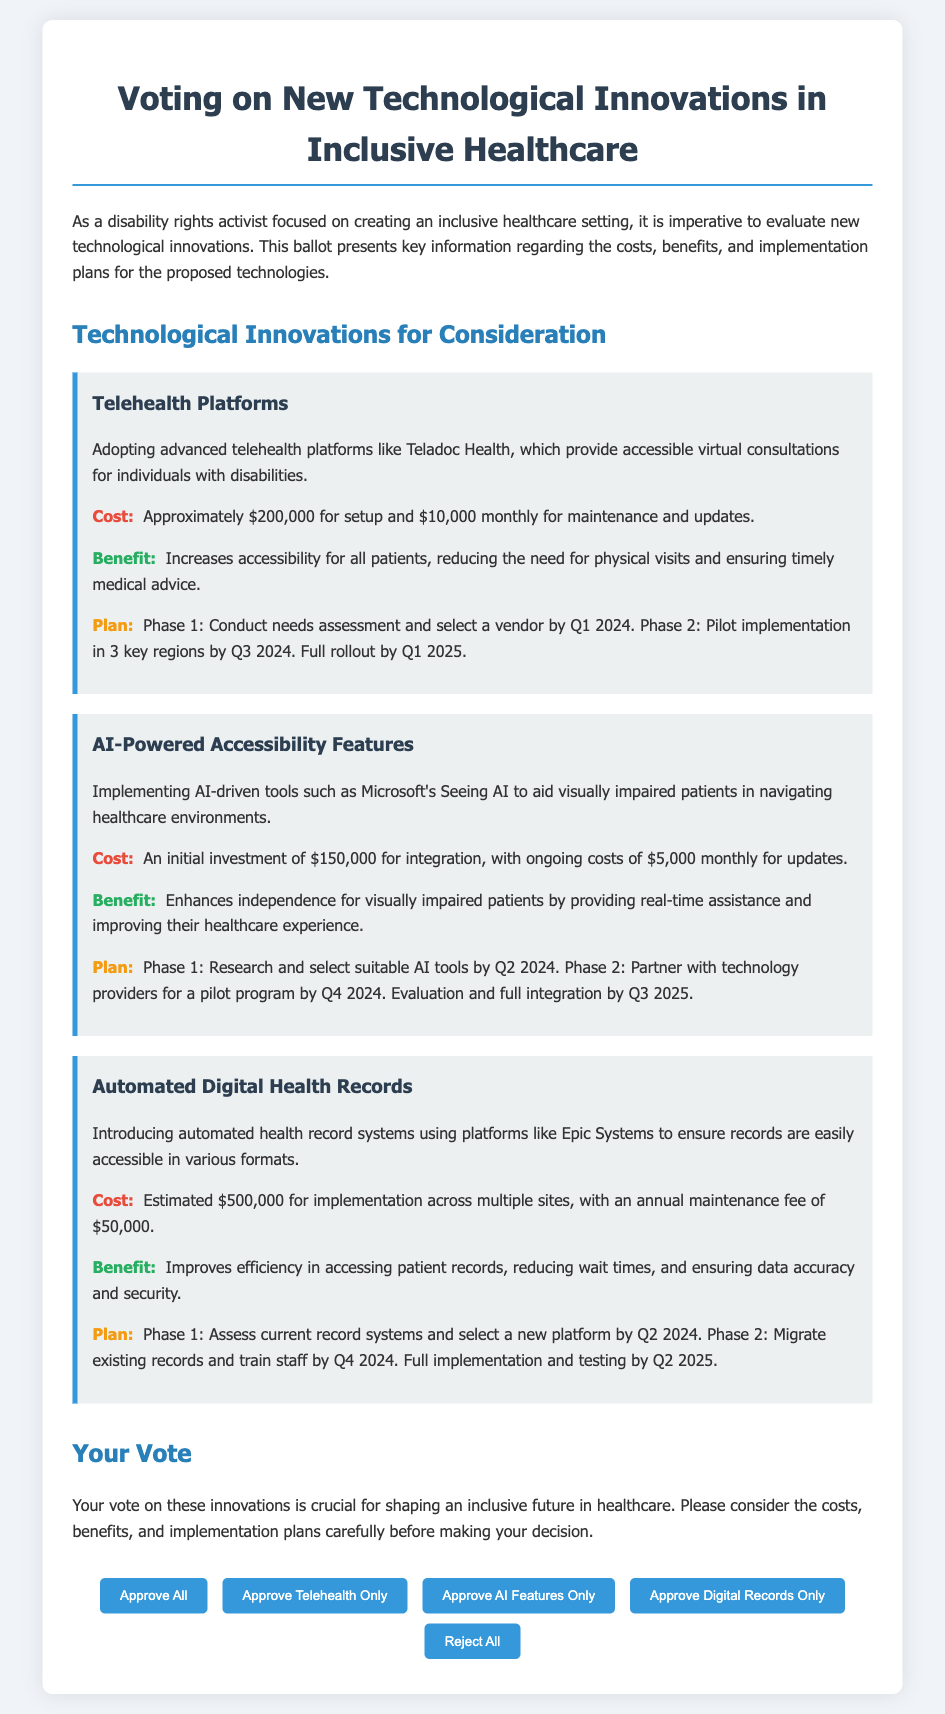What is the setup cost for Telehealth Platforms? The setup cost for Telehealth Platforms is mentioned as approximately $200,000.
Answer: $200,000 What is the ongoing monthly cost for AI-Powered Accessibility Features? The ongoing cost for AI-Powered Accessibility Features is detailed as $5,000 monthly for updates.
Answer: $5,000 What is the main benefit of Automated Digital Health Records? The main benefit of Automated Digital Health Records is improving efficiency in accessing patient records.
Answer: Improving efficiency What is the timeline for the full rollout of Telehealth Platforms? The full rollout of Telehealth Platforms is expected by Q1 2025 as per the implementation plan.
Answer: Q1 2025 What company provides AI-driven tools for visually impaired patients? The document mentions Microsoft's Seeing AI as the tool for visually impaired patients.
Answer: Microsoft How many phases are outlined for the implementation plan of AI-Powered Accessibility Features? The implementation plan for AI-Powered Accessibility Features consists of two phases.
Answer: Two phases What is the estimated maintenance fee for Automated Digital Health Records? The document specifies an annual maintenance fee of $50,000 for Automated Digital Health Records.
Answer: $50,000 What button allows voters to approve all innovations at once? The button labeled "Approve All" allows voters to approve all technological innovations at once.
Answer: Approve All Which technology is the last one presented for consideration? The last technology presented for consideration in the document is Automated Digital Health Records.
Answer: Automated Digital Health Records 